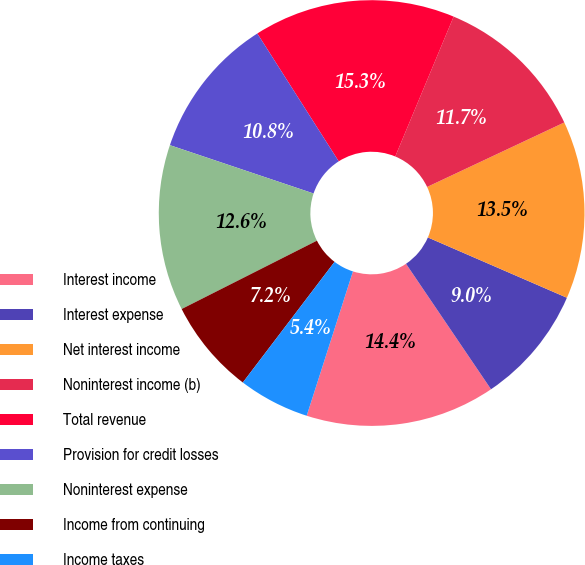<chart> <loc_0><loc_0><loc_500><loc_500><pie_chart><fcel>Interest income<fcel>Interest expense<fcel>Net interest income<fcel>Noninterest income (b)<fcel>Total revenue<fcel>Provision for credit losses<fcel>Noninterest expense<fcel>Income from continuing<fcel>Income taxes<nl><fcel>14.41%<fcel>9.01%<fcel>13.51%<fcel>11.71%<fcel>15.32%<fcel>10.81%<fcel>12.61%<fcel>7.21%<fcel>5.41%<nl></chart> 